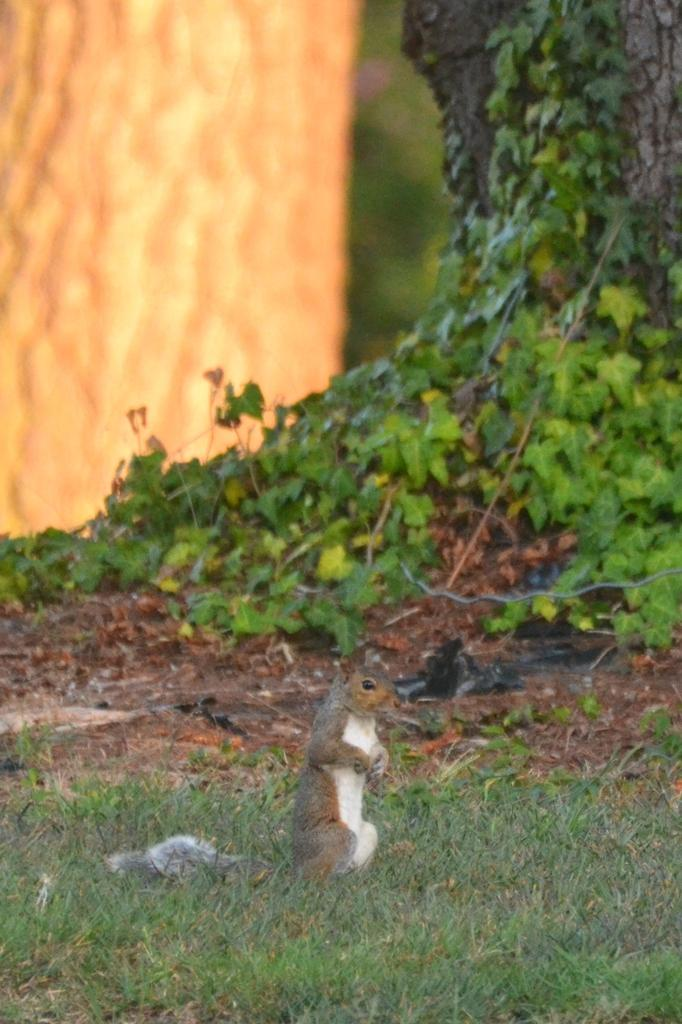What animal can be seen in the image? There is a squirrel in the image. Where is the squirrel located? The squirrel is on the grass. What can be seen in the background of the image? There are plants and a tree trunk in the background of the image. How would you describe the quality of the image? The image has a blurry view. What type of war is being fought in the image? There is no war present in the image; it features a squirrel on the grass with plants and a tree trunk in the background. 